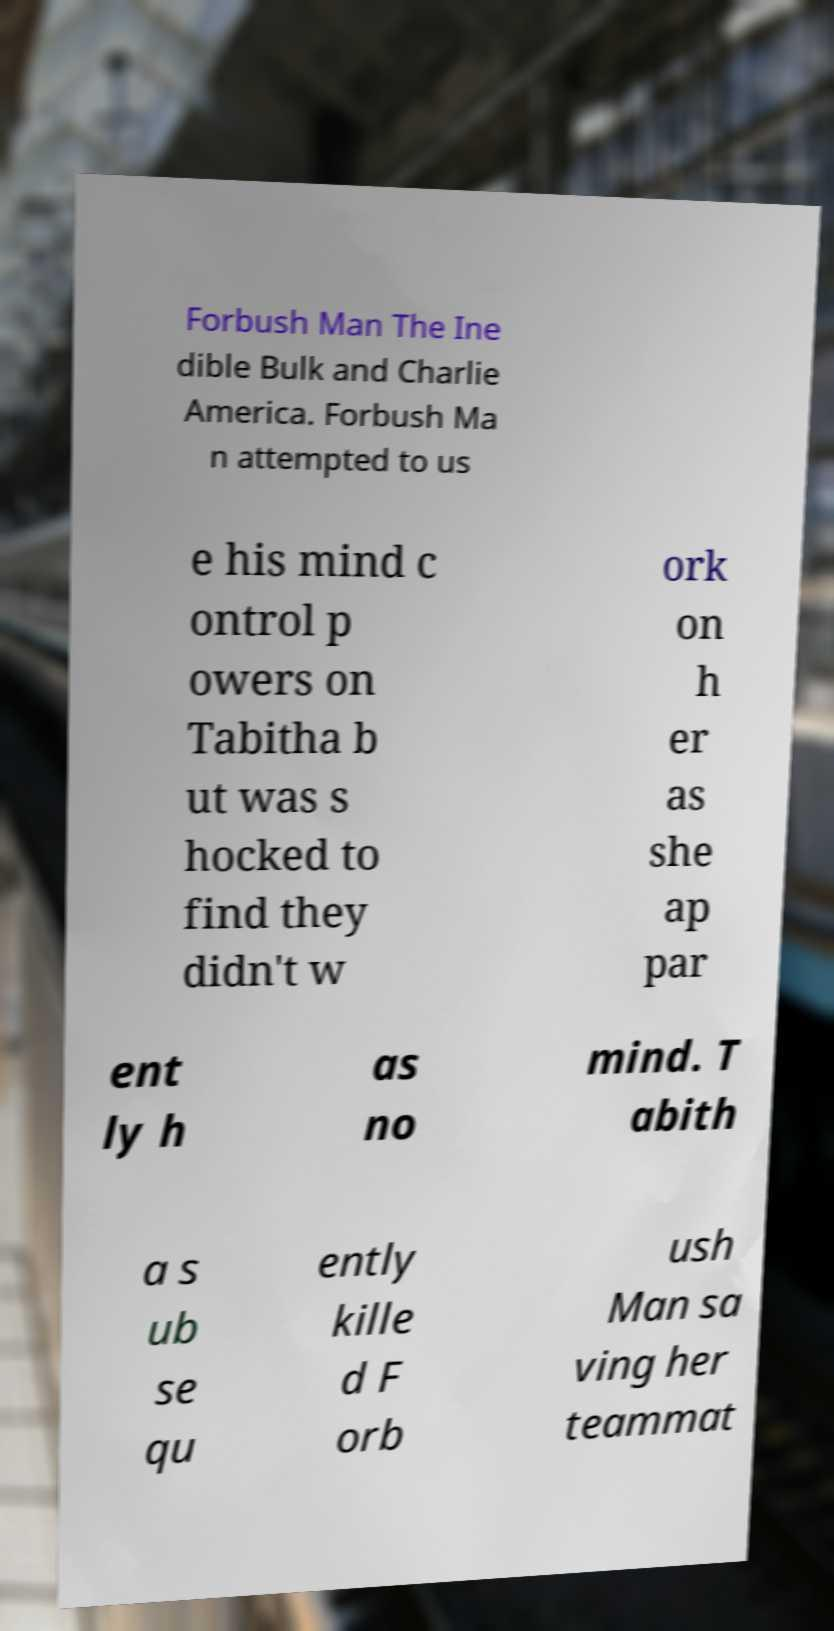Can you read and provide the text displayed in the image?This photo seems to have some interesting text. Can you extract and type it out for me? Forbush Man The Ine dible Bulk and Charlie America. Forbush Ma n attempted to us e his mind c ontrol p owers on Tabitha b ut was s hocked to find they didn't w ork on h er as she ap par ent ly h as no mind. T abith a s ub se qu ently kille d F orb ush Man sa ving her teammat 